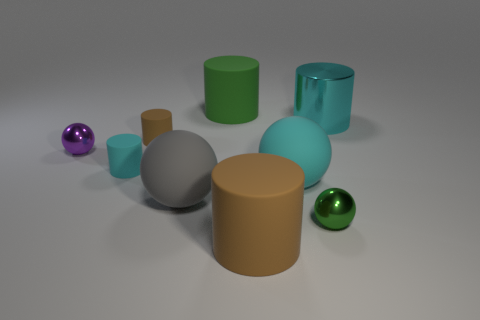There is a cyan cylinder that is made of the same material as the tiny brown cylinder; what is its size?
Provide a short and direct response. Small. Do the cyan matte cylinder and the shiny object that is in front of the tiny purple ball have the same size?
Your answer should be very brief. Yes. There is a matte object that is behind the small cyan cylinder and left of the gray matte ball; what color is it?
Your answer should be compact. Brown. How many things are either big cylinders behind the large cyan cylinder or balls in front of the tiny purple ball?
Provide a short and direct response. 4. There is a small ball that is behind the small shiny thing in front of the large cyan thing that is left of the metal cylinder; what color is it?
Make the answer very short. Purple. Are there any green metallic things of the same shape as the tiny brown object?
Make the answer very short. No. How many green rubber things are there?
Ensure brevity in your answer.  1. The tiny green metal thing is what shape?
Provide a short and direct response. Sphere. What number of cyan metal things are the same size as the purple sphere?
Keep it short and to the point. 0. Is the large brown object the same shape as the tiny brown thing?
Your response must be concise. Yes. 